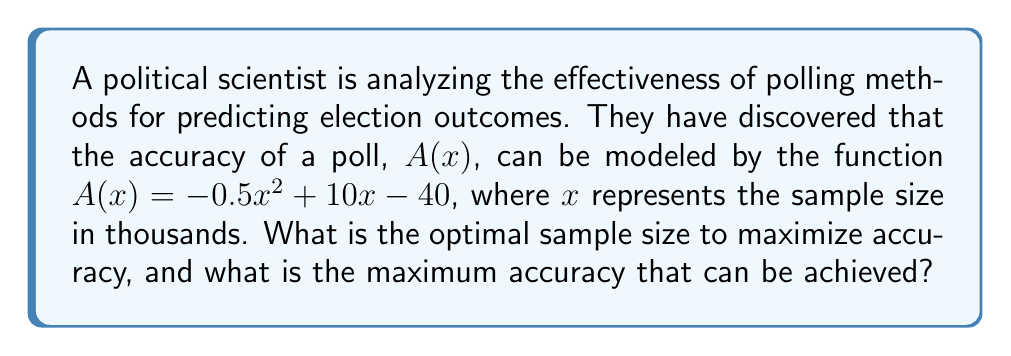Show me your answer to this math problem. To solve this problem, we need to find the maximum value of the function $A(x) = -0.5x^2 + 10x - 40$ using calculus techniques. This involves finding the critical points and determining which one yields the maximum value.

Step 1: Find the derivative of $A(x)$
$$A'(x) = -x + 10$$

Step 2: Set the derivative equal to zero and solve for x
$$-x + 10 = 0$$
$$x = 10$$

Step 3: Verify that this critical point is a maximum
The second derivative is $A''(x) = -1$, which is negative. This confirms that $x = 10$ is a maximum point.

Step 4: Calculate the maximum accuracy
Substitute $x = 10$ into the original function:
$$A(10) = -0.5(10)^2 + 10(10) - 40$$
$$A(10) = -50 + 100 - 40 = 10$$

Therefore, the optimal sample size is 10,000 (since x was in thousands), and the maximum accuracy that can be achieved is 10.

This result suggests that increasing the sample size beyond 10,000 would not improve the accuracy of the poll, and may even decrease it due to factors such as increased costs or potential sampling biases.
Answer: Optimal sample size: 10,000; Maximum accuracy: 10 